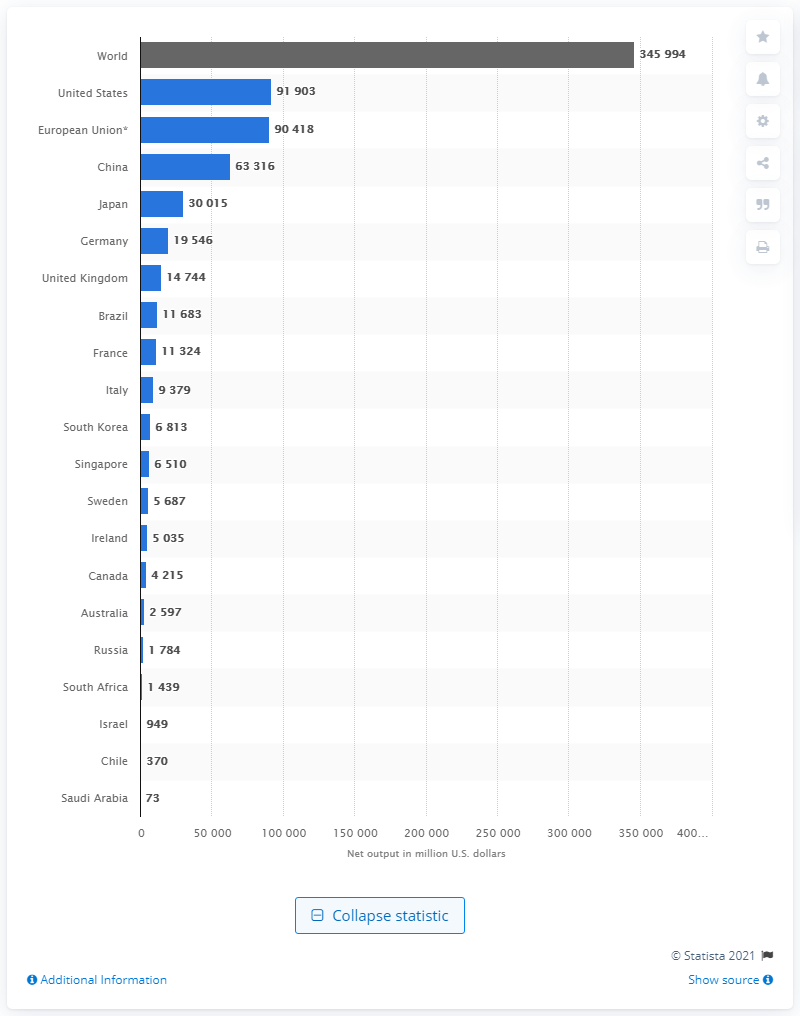Can you identify any trends or insights from the data shown in the image? The image reveals that the largest outputs in pharmaceuticals are concentrated heavily in developed countries, with the United States and the combined European Union leading by a significant margin. This suggests a correlation between economic development and pharmaceutical production capacity. What might be the reason for the relatively low output of pharmaceuticals in countries like Saudi Arabia and Chile? Several factors could influence the low pharmaceutical output in these countries, such as smaller market size, lower investment in pharmaceutical manufacturing, differing national priorities, and reliance on imports for pharmaceuticals. 